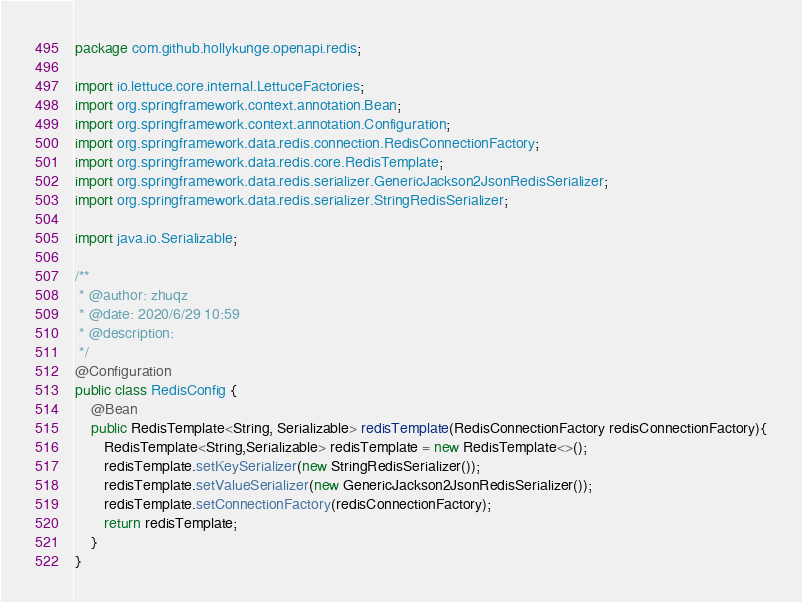<code> <loc_0><loc_0><loc_500><loc_500><_Java_>package com.github.hollykunge.openapi.redis;

import io.lettuce.core.internal.LettuceFactories;
import org.springframework.context.annotation.Bean;
import org.springframework.context.annotation.Configuration;
import org.springframework.data.redis.connection.RedisConnectionFactory;
import org.springframework.data.redis.core.RedisTemplate;
import org.springframework.data.redis.serializer.GenericJackson2JsonRedisSerializer;
import org.springframework.data.redis.serializer.StringRedisSerializer;

import java.io.Serializable;

/**
 * @author: zhuqz
 * @date: 2020/6/29 10:59
 * @description:
 */
@Configuration
public class RedisConfig {
    @Bean
    public RedisTemplate<String, Serializable> redisTemplate(RedisConnectionFactory redisConnectionFactory){
       RedisTemplate<String,Serializable> redisTemplate = new RedisTemplate<>();
       redisTemplate.setKeySerializer(new StringRedisSerializer());
       redisTemplate.setValueSerializer(new GenericJackson2JsonRedisSerializer());
       redisTemplate.setConnectionFactory(redisConnectionFactory);
       return redisTemplate;
    }
}</code> 